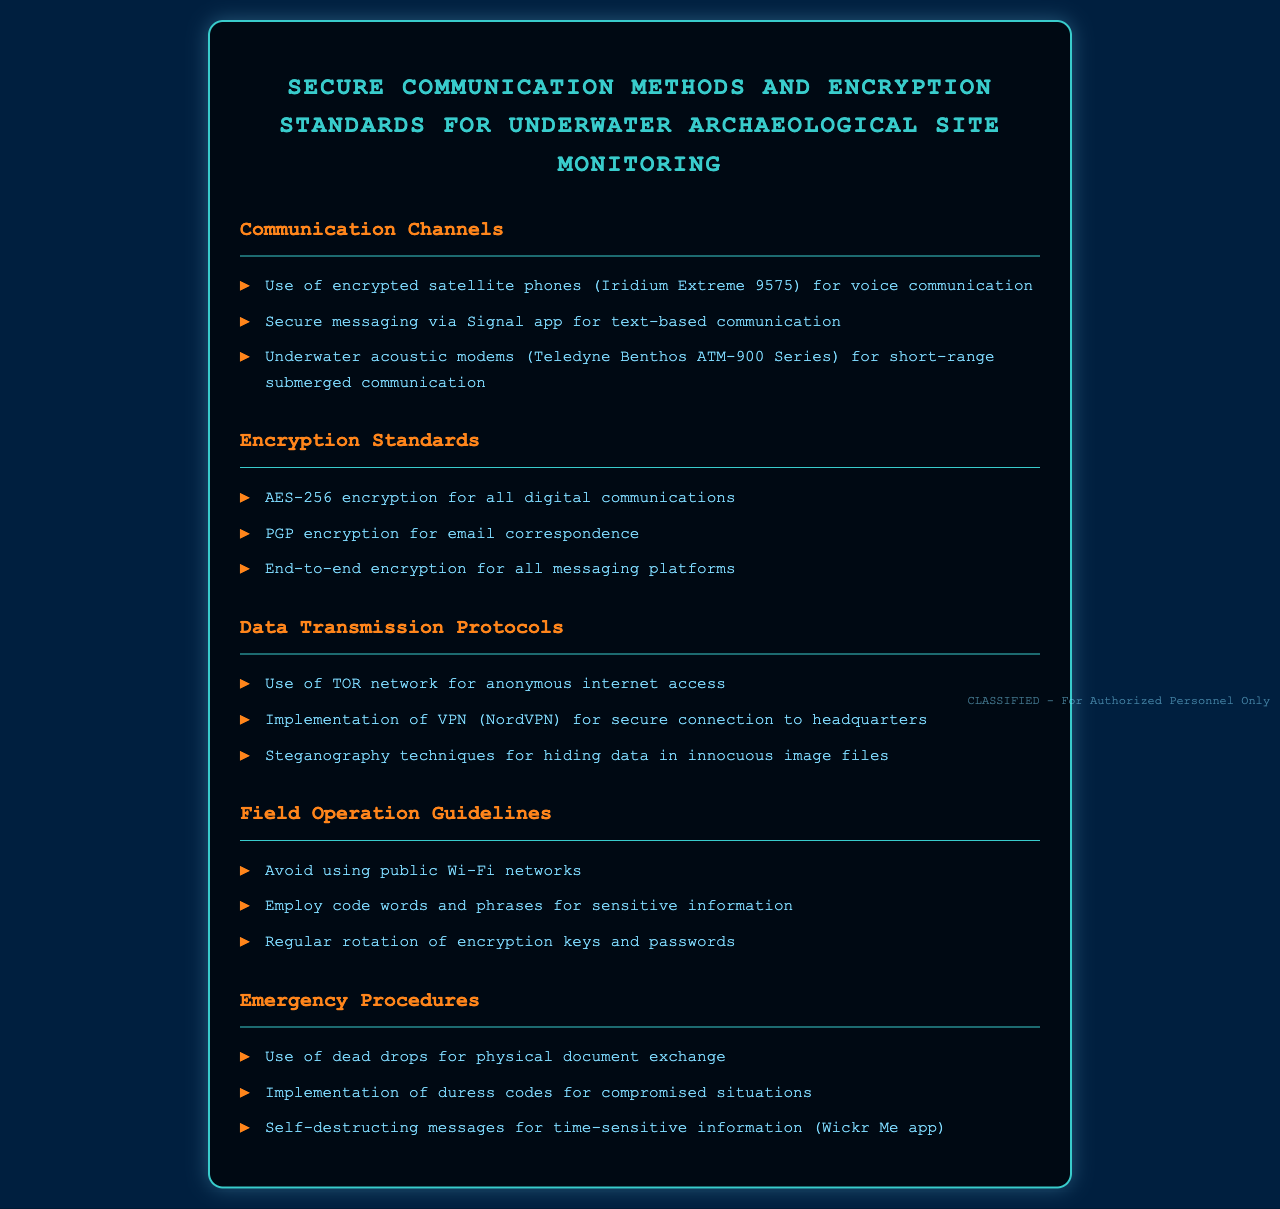What is the main title of the document? The main title is located at the top of the document and outlines the subject matter.
Answer: Secure Communication Methods and Encryption Standards for Underwater Archaeological Site Monitoring How many communication channels are listed? There is a section titled "Communication Channels" that lists multiple methods of communication.
Answer: Three What encryption standard is mentioned for email correspondence? The document specifies a particular standard for email within the "Encryption Standards" section.
Answer: PGP encryption What should operatives avoid using according to the field operation guidelines? A specific guidance is provided in the "Field Operation Guidelines" regarding network usage.
Answer: Public Wi-Fi networks What type of encryption is used for all digital communications? The document states a particular encryption standard for digital communications listed under "Encryption Standards."
Answer: AES-256 encryption What is the purpose of using duress codes? The document explains a specific emergency procedure that includes the use of duress codes.
Answer: Compromised situations Which application is mentioned for self-destructing messages? The document refers to a specific application that facilitates self-destructing messages in the "Emergency Procedures" section.
Answer: Wickr Me app What type of modem is used for underwater communication? The document identifies a specific type of modem in the communication section tailored for underwater scenarios.
Answer: Teledyne Benthos ATM-900 Series How often should encryption keys and passwords be rotated? The document implies a regular practice concerning encryption in the "Field Operation Guidelines" section.
Answer: Regularly 